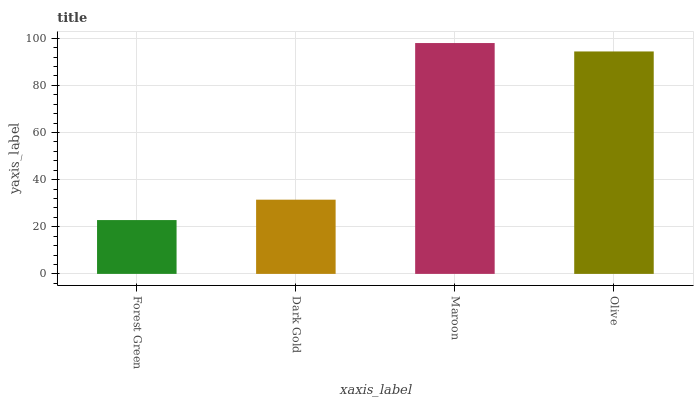Is Forest Green the minimum?
Answer yes or no. Yes. Is Maroon the maximum?
Answer yes or no. Yes. Is Dark Gold the minimum?
Answer yes or no. No. Is Dark Gold the maximum?
Answer yes or no. No. Is Dark Gold greater than Forest Green?
Answer yes or no. Yes. Is Forest Green less than Dark Gold?
Answer yes or no. Yes. Is Forest Green greater than Dark Gold?
Answer yes or no. No. Is Dark Gold less than Forest Green?
Answer yes or no. No. Is Olive the high median?
Answer yes or no. Yes. Is Dark Gold the low median?
Answer yes or no. Yes. Is Dark Gold the high median?
Answer yes or no. No. Is Olive the low median?
Answer yes or no. No. 